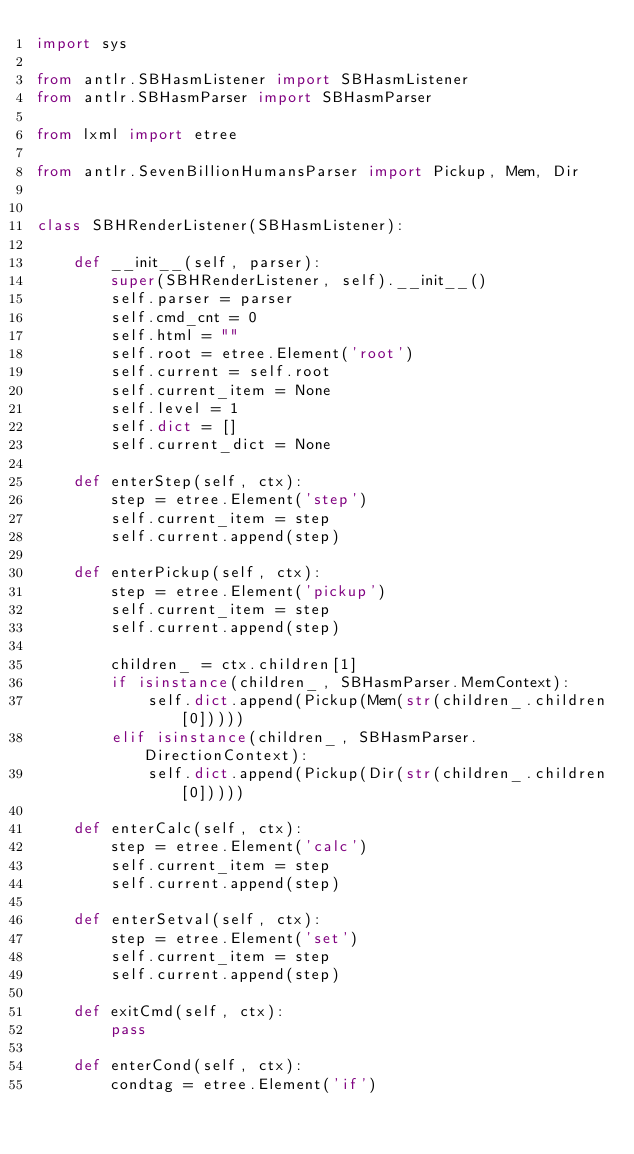<code> <loc_0><loc_0><loc_500><loc_500><_Python_>import sys

from antlr.SBHasmListener import SBHasmListener
from antlr.SBHasmParser import SBHasmParser

from lxml import etree

from antlr.SevenBillionHumansParser import Pickup, Mem, Dir


class SBHRenderListener(SBHasmListener):

    def __init__(self, parser):
        super(SBHRenderListener, self).__init__()
        self.parser = parser
        self.cmd_cnt = 0
        self.html = ""
        self.root = etree.Element('root')
        self.current = self.root
        self.current_item = None
        self.level = 1
        self.dict = []
        self.current_dict = None

    def enterStep(self, ctx):
        step = etree.Element('step')
        self.current_item = step
        self.current.append(step)

    def enterPickup(self, ctx):
        step = etree.Element('pickup')
        self.current_item = step
        self.current.append(step)

        children_ = ctx.children[1]
        if isinstance(children_, SBHasmParser.MemContext):
            self.dict.append(Pickup(Mem(str(children_.children[0]))))
        elif isinstance(children_, SBHasmParser.DirectionContext):
            self.dict.append(Pickup(Dir(str(children_.children[0]))))

    def enterCalc(self, ctx):
        step = etree.Element('calc')
        self.current_item = step
        self.current.append(step)

    def enterSetval(self, ctx):
        step = etree.Element('set')
        self.current_item = step
        self.current.append(step)

    def exitCmd(self, ctx):
        pass

    def enterCond(self, ctx):
        condtag = etree.Element('if')</code> 